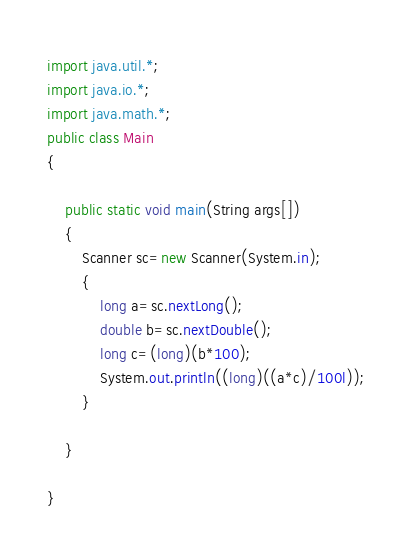<code> <loc_0><loc_0><loc_500><loc_500><_Java_>import java.util.*;
import java.io.*;
import java.math.*;
public class Main
{
  
    public static void main(String args[])
    {
        Scanner sc=new Scanner(System.in);
        {
            long a=sc.nextLong();
            double b=sc.nextDouble();
            long c=(long)(b*100);
            System.out.println((long)((a*c)/100l));
        }
            
    }
   
}</code> 